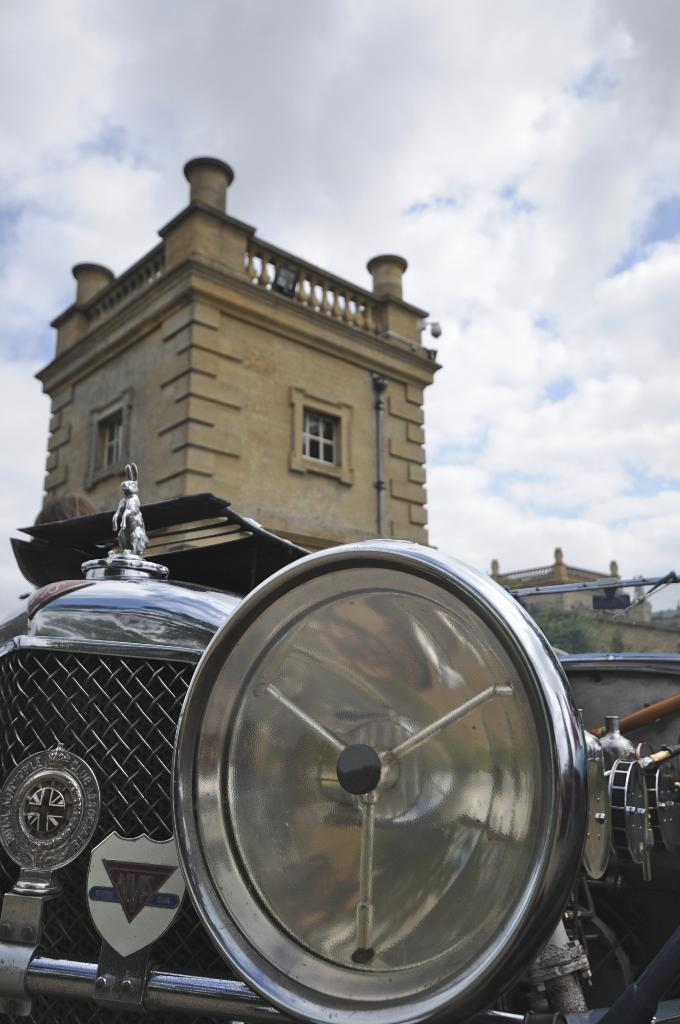What is the main subject of the image? There is a car in the image. What can be seen in the background of the image? There are buildings with windows and trees visible in the image. How would you describe the sky in the image? The sky is visible in the image and appears cloudy. How does the car use its nose to navigate through the fog in the image? There is no fog present in the image, and cars do not have noses to navigate. 